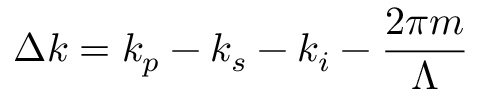<formula> <loc_0><loc_0><loc_500><loc_500>\Delta k = k _ { p } - k _ { s } - k _ { i } - \frac { 2 \pi m } { \Lambda }</formula> 